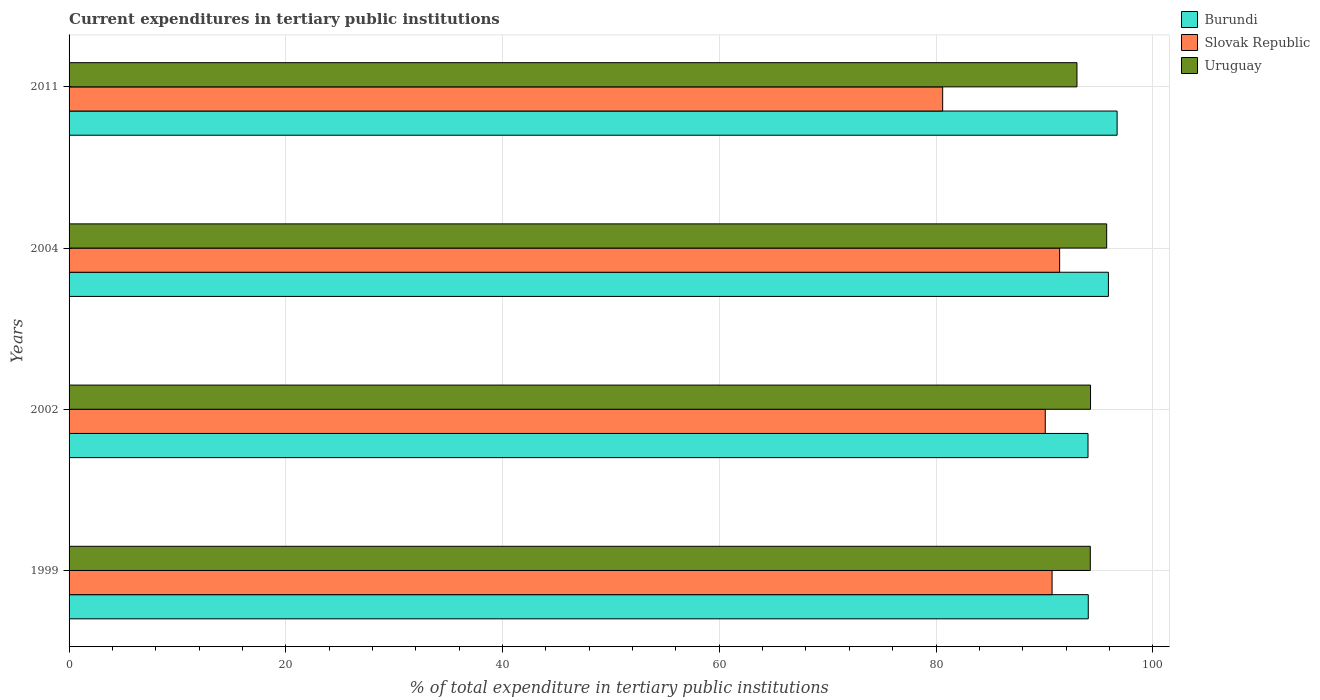How many different coloured bars are there?
Keep it short and to the point. 3. How many groups of bars are there?
Offer a terse response. 4. Are the number of bars on each tick of the Y-axis equal?
Your response must be concise. Yes. How many bars are there on the 2nd tick from the top?
Provide a succinct answer. 3. How many bars are there on the 3rd tick from the bottom?
Ensure brevity in your answer.  3. What is the label of the 1st group of bars from the top?
Give a very brief answer. 2011. In how many cases, is the number of bars for a given year not equal to the number of legend labels?
Ensure brevity in your answer.  0. What is the current expenditures in tertiary public institutions in Burundi in 2002?
Offer a very short reply. 94.03. Across all years, what is the maximum current expenditures in tertiary public institutions in Uruguay?
Your response must be concise. 95.75. Across all years, what is the minimum current expenditures in tertiary public institutions in Uruguay?
Your answer should be very brief. 93.01. In which year was the current expenditures in tertiary public institutions in Burundi minimum?
Offer a terse response. 2002. What is the total current expenditures in tertiary public institutions in Uruguay in the graph?
Make the answer very short. 377.26. What is the difference between the current expenditures in tertiary public institutions in Burundi in 1999 and that in 2011?
Offer a terse response. -2.66. What is the difference between the current expenditures in tertiary public institutions in Slovak Republic in 2004 and the current expenditures in tertiary public institutions in Uruguay in 2002?
Ensure brevity in your answer.  -2.85. What is the average current expenditures in tertiary public institutions in Uruguay per year?
Your answer should be compact. 94.31. In the year 2004, what is the difference between the current expenditures in tertiary public institutions in Burundi and current expenditures in tertiary public institutions in Slovak Republic?
Give a very brief answer. 4.5. In how many years, is the current expenditures in tertiary public institutions in Uruguay greater than 68 %?
Keep it short and to the point. 4. What is the ratio of the current expenditures in tertiary public institutions in Slovak Republic in 1999 to that in 2004?
Your answer should be very brief. 0.99. Is the difference between the current expenditures in tertiary public institutions in Burundi in 1999 and 2002 greater than the difference between the current expenditures in tertiary public institutions in Slovak Republic in 1999 and 2002?
Provide a succinct answer. No. What is the difference between the highest and the second highest current expenditures in tertiary public institutions in Burundi?
Keep it short and to the point. 0.8. What is the difference between the highest and the lowest current expenditures in tertiary public institutions in Burundi?
Offer a terse response. 2.68. In how many years, is the current expenditures in tertiary public institutions in Slovak Republic greater than the average current expenditures in tertiary public institutions in Slovak Republic taken over all years?
Your answer should be compact. 3. Is the sum of the current expenditures in tertiary public institutions in Uruguay in 2004 and 2011 greater than the maximum current expenditures in tertiary public institutions in Burundi across all years?
Give a very brief answer. Yes. What does the 3rd bar from the top in 2002 represents?
Offer a terse response. Burundi. What does the 2nd bar from the bottom in 2004 represents?
Give a very brief answer. Slovak Republic. How many bars are there?
Offer a terse response. 12. How many years are there in the graph?
Ensure brevity in your answer.  4. Are the values on the major ticks of X-axis written in scientific E-notation?
Provide a short and direct response. No. Does the graph contain any zero values?
Provide a short and direct response. No. Where does the legend appear in the graph?
Keep it short and to the point. Top right. What is the title of the graph?
Keep it short and to the point. Current expenditures in tertiary public institutions. What is the label or title of the X-axis?
Offer a terse response. % of total expenditure in tertiary public institutions. What is the label or title of the Y-axis?
Your answer should be very brief. Years. What is the % of total expenditure in tertiary public institutions of Burundi in 1999?
Your response must be concise. 94.05. What is the % of total expenditure in tertiary public institutions of Slovak Republic in 1999?
Make the answer very short. 90.71. What is the % of total expenditure in tertiary public institutions in Uruguay in 1999?
Provide a short and direct response. 94.24. What is the % of total expenditure in tertiary public institutions of Burundi in 2002?
Your answer should be very brief. 94.03. What is the % of total expenditure in tertiary public institutions in Slovak Republic in 2002?
Provide a succinct answer. 90.08. What is the % of total expenditure in tertiary public institutions of Uruguay in 2002?
Make the answer very short. 94.26. What is the % of total expenditure in tertiary public institutions in Burundi in 2004?
Give a very brief answer. 95.91. What is the % of total expenditure in tertiary public institutions of Slovak Republic in 2004?
Your response must be concise. 91.41. What is the % of total expenditure in tertiary public institutions of Uruguay in 2004?
Offer a very short reply. 95.75. What is the % of total expenditure in tertiary public institutions in Burundi in 2011?
Provide a short and direct response. 96.71. What is the % of total expenditure in tertiary public institutions in Slovak Republic in 2011?
Keep it short and to the point. 80.62. What is the % of total expenditure in tertiary public institutions of Uruguay in 2011?
Offer a very short reply. 93.01. Across all years, what is the maximum % of total expenditure in tertiary public institutions of Burundi?
Provide a succinct answer. 96.71. Across all years, what is the maximum % of total expenditure in tertiary public institutions of Slovak Republic?
Offer a terse response. 91.41. Across all years, what is the maximum % of total expenditure in tertiary public institutions in Uruguay?
Ensure brevity in your answer.  95.75. Across all years, what is the minimum % of total expenditure in tertiary public institutions of Burundi?
Your answer should be compact. 94.03. Across all years, what is the minimum % of total expenditure in tertiary public institutions of Slovak Republic?
Your answer should be very brief. 80.62. Across all years, what is the minimum % of total expenditure in tertiary public institutions in Uruguay?
Provide a short and direct response. 93.01. What is the total % of total expenditure in tertiary public institutions in Burundi in the graph?
Your answer should be very brief. 380.7. What is the total % of total expenditure in tertiary public institutions of Slovak Republic in the graph?
Offer a very short reply. 352.82. What is the total % of total expenditure in tertiary public institutions in Uruguay in the graph?
Your response must be concise. 377.26. What is the difference between the % of total expenditure in tertiary public institutions of Burundi in 1999 and that in 2002?
Offer a very short reply. 0.02. What is the difference between the % of total expenditure in tertiary public institutions in Slovak Republic in 1999 and that in 2002?
Your answer should be compact. 0.63. What is the difference between the % of total expenditure in tertiary public institutions of Uruguay in 1999 and that in 2002?
Provide a short and direct response. -0.02. What is the difference between the % of total expenditure in tertiary public institutions of Burundi in 1999 and that in 2004?
Make the answer very short. -1.86. What is the difference between the % of total expenditure in tertiary public institutions of Slovak Republic in 1999 and that in 2004?
Provide a short and direct response. -0.7. What is the difference between the % of total expenditure in tertiary public institutions of Uruguay in 1999 and that in 2004?
Offer a very short reply. -1.51. What is the difference between the % of total expenditure in tertiary public institutions in Burundi in 1999 and that in 2011?
Provide a succinct answer. -2.66. What is the difference between the % of total expenditure in tertiary public institutions in Slovak Republic in 1999 and that in 2011?
Offer a terse response. 10.1. What is the difference between the % of total expenditure in tertiary public institutions in Uruguay in 1999 and that in 2011?
Offer a terse response. 1.23. What is the difference between the % of total expenditure in tertiary public institutions in Burundi in 2002 and that in 2004?
Make the answer very short. -1.88. What is the difference between the % of total expenditure in tertiary public institutions of Slovak Republic in 2002 and that in 2004?
Offer a very short reply. -1.33. What is the difference between the % of total expenditure in tertiary public institutions in Uruguay in 2002 and that in 2004?
Provide a short and direct response. -1.49. What is the difference between the % of total expenditure in tertiary public institutions in Burundi in 2002 and that in 2011?
Your response must be concise. -2.68. What is the difference between the % of total expenditure in tertiary public institutions in Slovak Republic in 2002 and that in 2011?
Your response must be concise. 9.47. What is the difference between the % of total expenditure in tertiary public institutions of Uruguay in 2002 and that in 2011?
Your answer should be very brief. 1.25. What is the difference between the % of total expenditure in tertiary public institutions of Burundi in 2004 and that in 2011?
Your response must be concise. -0.8. What is the difference between the % of total expenditure in tertiary public institutions in Slovak Republic in 2004 and that in 2011?
Offer a very short reply. 10.79. What is the difference between the % of total expenditure in tertiary public institutions of Uruguay in 2004 and that in 2011?
Your answer should be compact. 2.74. What is the difference between the % of total expenditure in tertiary public institutions in Burundi in 1999 and the % of total expenditure in tertiary public institutions in Slovak Republic in 2002?
Your answer should be compact. 3.97. What is the difference between the % of total expenditure in tertiary public institutions of Burundi in 1999 and the % of total expenditure in tertiary public institutions of Uruguay in 2002?
Ensure brevity in your answer.  -0.21. What is the difference between the % of total expenditure in tertiary public institutions in Slovak Republic in 1999 and the % of total expenditure in tertiary public institutions in Uruguay in 2002?
Offer a very short reply. -3.55. What is the difference between the % of total expenditure in tertiary public institutions in Burundi in 1999 and the % of total expenditure in tertiary public institutions in Slovak Republic in 2004?
Make the answer very short. 2.64. What is the difference between the % of total expenditure in tertiary public institutions in Burundi in 1999 and the % of total expenditure in tertiary public institutions in Uruguay in 2004?
Provide a succinct answer. -1.7. What is the difference between the % of total expenditure in tertiary public institutions of Slovak Republic in 1999 and the % of total expenditure in tertiary public institutions of Uruguay in 2004?
Provide a short and direct response. -5.04. What is the difference between the % of total expenditure in tertiary public institutions of Burundi in 1999 and the % of total expenditure in tertiary public institutions of Slovak Republic in 2011?
Provide a succinct answer. 13.44. What is the difference between the % of total expenditure in tertiary public institutions in Burundi in 1999 and the % of total expenditure in tertiary public institutions in Uruguay in 2011?
Your response must be concise. 1.04. What is the difference between the % of total expenditure in tertiary public institutions in Slovak Republic in 1999 and the % of total expenditure in tertiary public institutions in Uruguay in 2011?
Offer a terse response. -2.3. What is the difference between the % of total expenditure in tertiary public institutions of Burundi in 2002 and the % of total expenditure in tertiary public institutions of Slovak Republic in 2004?
Ensure brevity in your answer.  2.62. What is the difference between the % of total expenditure in tertiary public institutions in Burundi in 2002 and the % of total expenditure in tertiary public institutions in Uruguay in 2004?
Your response must be concise. -1.72. What is the difference between the % of total expenditure in tertiary public institutions of Slovak Republic in 2002 and the % of total expenditure in tertiary public institutions of Uruguay in 2004?
Offer a very short reply. -5.67. What is the difference between the % of total expenditure in tertiary public institutions of Burundi in 2002 and the % of total expenditure in tertiary public institutions of Slovak Republic in 2011?
Give a very brief answer. 13.41. What is the difference between the % of total expenditure in tertiary public institutions in Burundi in 2002 and the % of total expenditure in tertiary public institutions in Uruguay in 2011?
Make the answer very short. 1.02. What is the difference between the % of total expenditure in tertiary public institutions in Slovak Republic in 2002 and the % of total expenditure in tertiary public institutions in Uruguay in 2011?
Keep it short and to the point. -2.93. What is the difference between the % of total expenditure in tertiary public institutions of Burundi in 2004 and the % of total expenditure in tertiary public institutions of Slovak Republic in 2011?
Your response must be concise. 15.29. What is the difference between the % of total expenditure in tertiary public institutions in Burundi in 2004 and the % of total expenditure in tertiary public institutions in Uruguay in 2011?
Keep it short and to the point. 2.9. What is the difference between the % of total expenditure in tertiary public institutions in Slovak Republic in 2004 and the % of total expenditure in tertiary public institutions in Uruguay in 2011?
Offer a terse response. -1.6. What is the average % of total expenditure in tertiary public institutions of Burundi per year?
Provide a short and direct response. 95.18. What is the average % of total expenditure in tertiary public institutions in Slovak Republic per year?
Provide a succinct answer. 88.2. What is the average % of total expenditure in tertiary public institutions of Uruguay per year?
Provide a short and direct response. 94.31. In the year 1999, what is the difference between the % of total expenditure in tertiary public institutions in Burundi and % of total expenditure in tertiary public institutions in Slovak Republic?
Give a very brief answer. 3.34. In the year 1999, what is the difference between the % of total expenditure in tertiary public institutions of Burundi and % of total expenditure in tertiary public institutions of Uruguay?
Make the answer very short. -0.19. In the year 1999, what is the difference between the % of total expenditure in tertiary public institutions in Slovak Republic and % of total expenditure in tertiary public institutions in Uruguay?
Provide a succinct answer. -3.53. In the year 2002, what is the difference between the % of total expenditure in tertiary public institutions of Burundi and % of total expenditure in tertiary public institutions of Slovak Republic?
Keep it short and to the point. 3.95. In the year 2002, what is the difference between the % of total expenditure in tertiary public institutions in Burundi and % of total expenditure in tertiary public institutions in Uruguay?
Your answer should be compact. -0.23. In the year 2002, what is the difference between the % of total expenditure in tertiary public institutions of Slovak Republic and % of total expenditure in tertiary public institutions of Uruguay?
Your response must be concise. -4.18. In the year 2004, what is the difference between the % of total expenditure in tertiary public institutions of Burundi and % of total expenditure in tertiary public institutions of Slovak Republic?
Offer a very short reply. 4.5. In the year 2004, what is the difference between the % of total expenditure in tertiary public institutions of Burundi and % of total expenditure in tertiary public institutions of Uruguay?
Give a very brief answer. 0.16. In the year 2004, what is the difference between the % of total expenditure in tertiary public institutions in Slovak Republic and % of total expenditure in tertiary public institutions in Uruguay?
Offer a very short reply. -4.34. In the year 2011, what is the difference between the % of total expenditure in tertiary public institutions of Burundi and % of total expenditure in tertiary public institutions of Slovak Republic?
Offer a very short reply. 16.1. In the year 2011, what is the difference between the % of total expenditure in tertiary public institutions of Burundi and % of total expenditure in tertiary public institutions of Uruguay?
Your response must be concise. 3.7. In the year 2011, what is the difference between the % of total expenditure in tertiary public institutions in Slovak Republic and % of total expenditure in tertiary public institutions in Uruguay?
Make the answer very short. -12.39. What is the ratio of the % of total expenditure in tertiary public institutions of Burundi in 1999 to that in 2004?
Keep it short and to the point. 0.98. What is the ratio of the % of total expenditure in tertiary public institutions of Uruguay in 1999 to that in 2004?
Provide a succinct answer. 0.98. What is the ratio of the % of total expenditure in tertiary public institutions in Burundi in 1999 to that in 2011?
Offer a terse response. 0.97. What is the ratio of the % of total expenditure in tertiary public institutions of Slovak Republic in 1999 to that in 2011?
Your answer should be very brief. 1.13. What is the ratio of the % of total expenditure in tertiary public institutions of Uruguay in 1999 to that in 2011?
Offer a terse response. 1.01. What is the ratio of the % of total expenditure in tertiary public institutions of Burundi in 2002 to that in 2004?
Your response must be concise. 0.98. What is the ratio of the % of total expenditure in tertiary public institutions of Slovak Republic in 2002 to that in 2004?
Offer a terse response. 0.99. What is the ratio of the % of total expenditure in tertiary public institutions in Uruguay in 2002 to that in 2004?
Provide a succinct answer. 0.98. What is the ratio of the % of total expenditure in tertiary public institutions in Burundi in 2002 to that in 2011?
Provide a succinct answer. 0.97. What is the ratio of the % of total expenditure in tertiary public institutions in Slovak Republic in 2002 to that in 2011?
Your response must be concise. 1.12. What is the ratio of the % of total expenditure in tertiary public institutions in Uruguay in 2002 to that in 2011?
Make the answer very short. 1.01. What is the ratio of the % of total expenditure in tertiary public institutions in Burundi in 2004 to that in 2011?
Give a very brief answer. 0.99. What is the ratio of the % of total expenditure in tertiary public institutions in Slovak Republic in 2004 to that in 2011?
Give a very brief answer. 1.13. What is the ratio of the % of total expenditure in tertiary public institutions of Uruguay in 2004 to that in 2011?
Offer a very short reply. 1.03. What is the difference between the highest and the second highest % of total expenditure in tertiary public institutions of Burundi?
Offer a terse response. 0.8. What is the difference between the highest and the second highest % of total expenditure in tertiary public institutions in Slovak Republic?
Your answer should be very brief. 0.7. What is the difference between the highest and the second highest % of total expenditure in tertiary public institutions in Uruguay?
Provide a succinct answer. 1.49. What is the difference between the highest and the lowest % of total expenditure in tertiary public institutions in Burundi?
Make the answer very short. 2.68. What is the difference between the highest and the lowest % of total expenditure in tertiary public institutions in Slovak Republic?
Your response must be concise. 10.79. What is the difference between the highest and the lowest % of total expenditure in tertiary public institutions in Uruguay?
Provide a succinct answer. 2.74. 